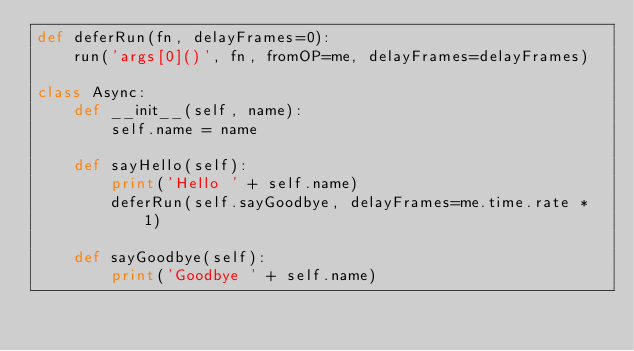Convert code to text. <code><loc_0><loc_0><loc_500><loc_500><_Python_>def deferRun(fn, delayFrames=0):
    run('args[0]()', fn, fromOP=me, delayFrames=delayFrames)

class Async:
    def __init__(self, name):
        self.name = name

    def sayHello(self):
        print('Hello ' + self.name)
        deferRun(self.sayGoodbye, delayFrames=me.time.rate * 1)

    def sayGoodbye(self):
        print('Goodbye ' + self.name)
</code> 